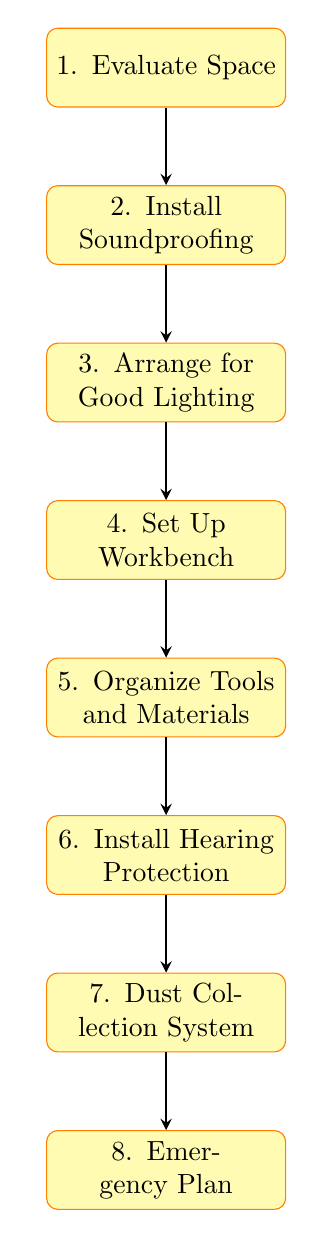What is the first step in the workshop setup process? The first step listed in the diagram is "Evaluate Space," which is crucial for determining where the workshop will be located.
Answer: Evaluate Space How many nodes are present in the diagram? The diagram contains a total of eight nodes, each representing a different step in the workshop setup process.
Answer: Eight What comes after "Install Soundproofing"? According to the flowchart, the step that follows "Install Soundproofing" is "Arrange for Good Lighting."
Answer: Arrange for Good Lighting What is the last step in the flowchart? The final step listed in the diagram is "Emergency Plan," which is essential for ensuring safety in case of unforeseen events.
Answer: Emergency Plan Which step directly leads to "Dust Collection System"? "Install Hearing Protection" directly leads to "Dust Collection System," based on the sequential flow shown in the diagram.
Answer: Install Hearing Protection What do the arrows in the diagram represent? The arrows indicate the flow of steps in the workshop setup process, showing the order in which each task should be completed.
Answer: Flow of steps Is the "Set Up Workbench" preceded by any step? Yes, "Set Up Workbench" is preceded by "Arrange for Good Lighting" based on the order established in the diagram.
Answer: Arrange for Good Lighting How many edges are in the diagram connecting the nodes? There are seven edges in the diagram, connecting the eight nodes to show the progression of steps.
Answer: Seven 